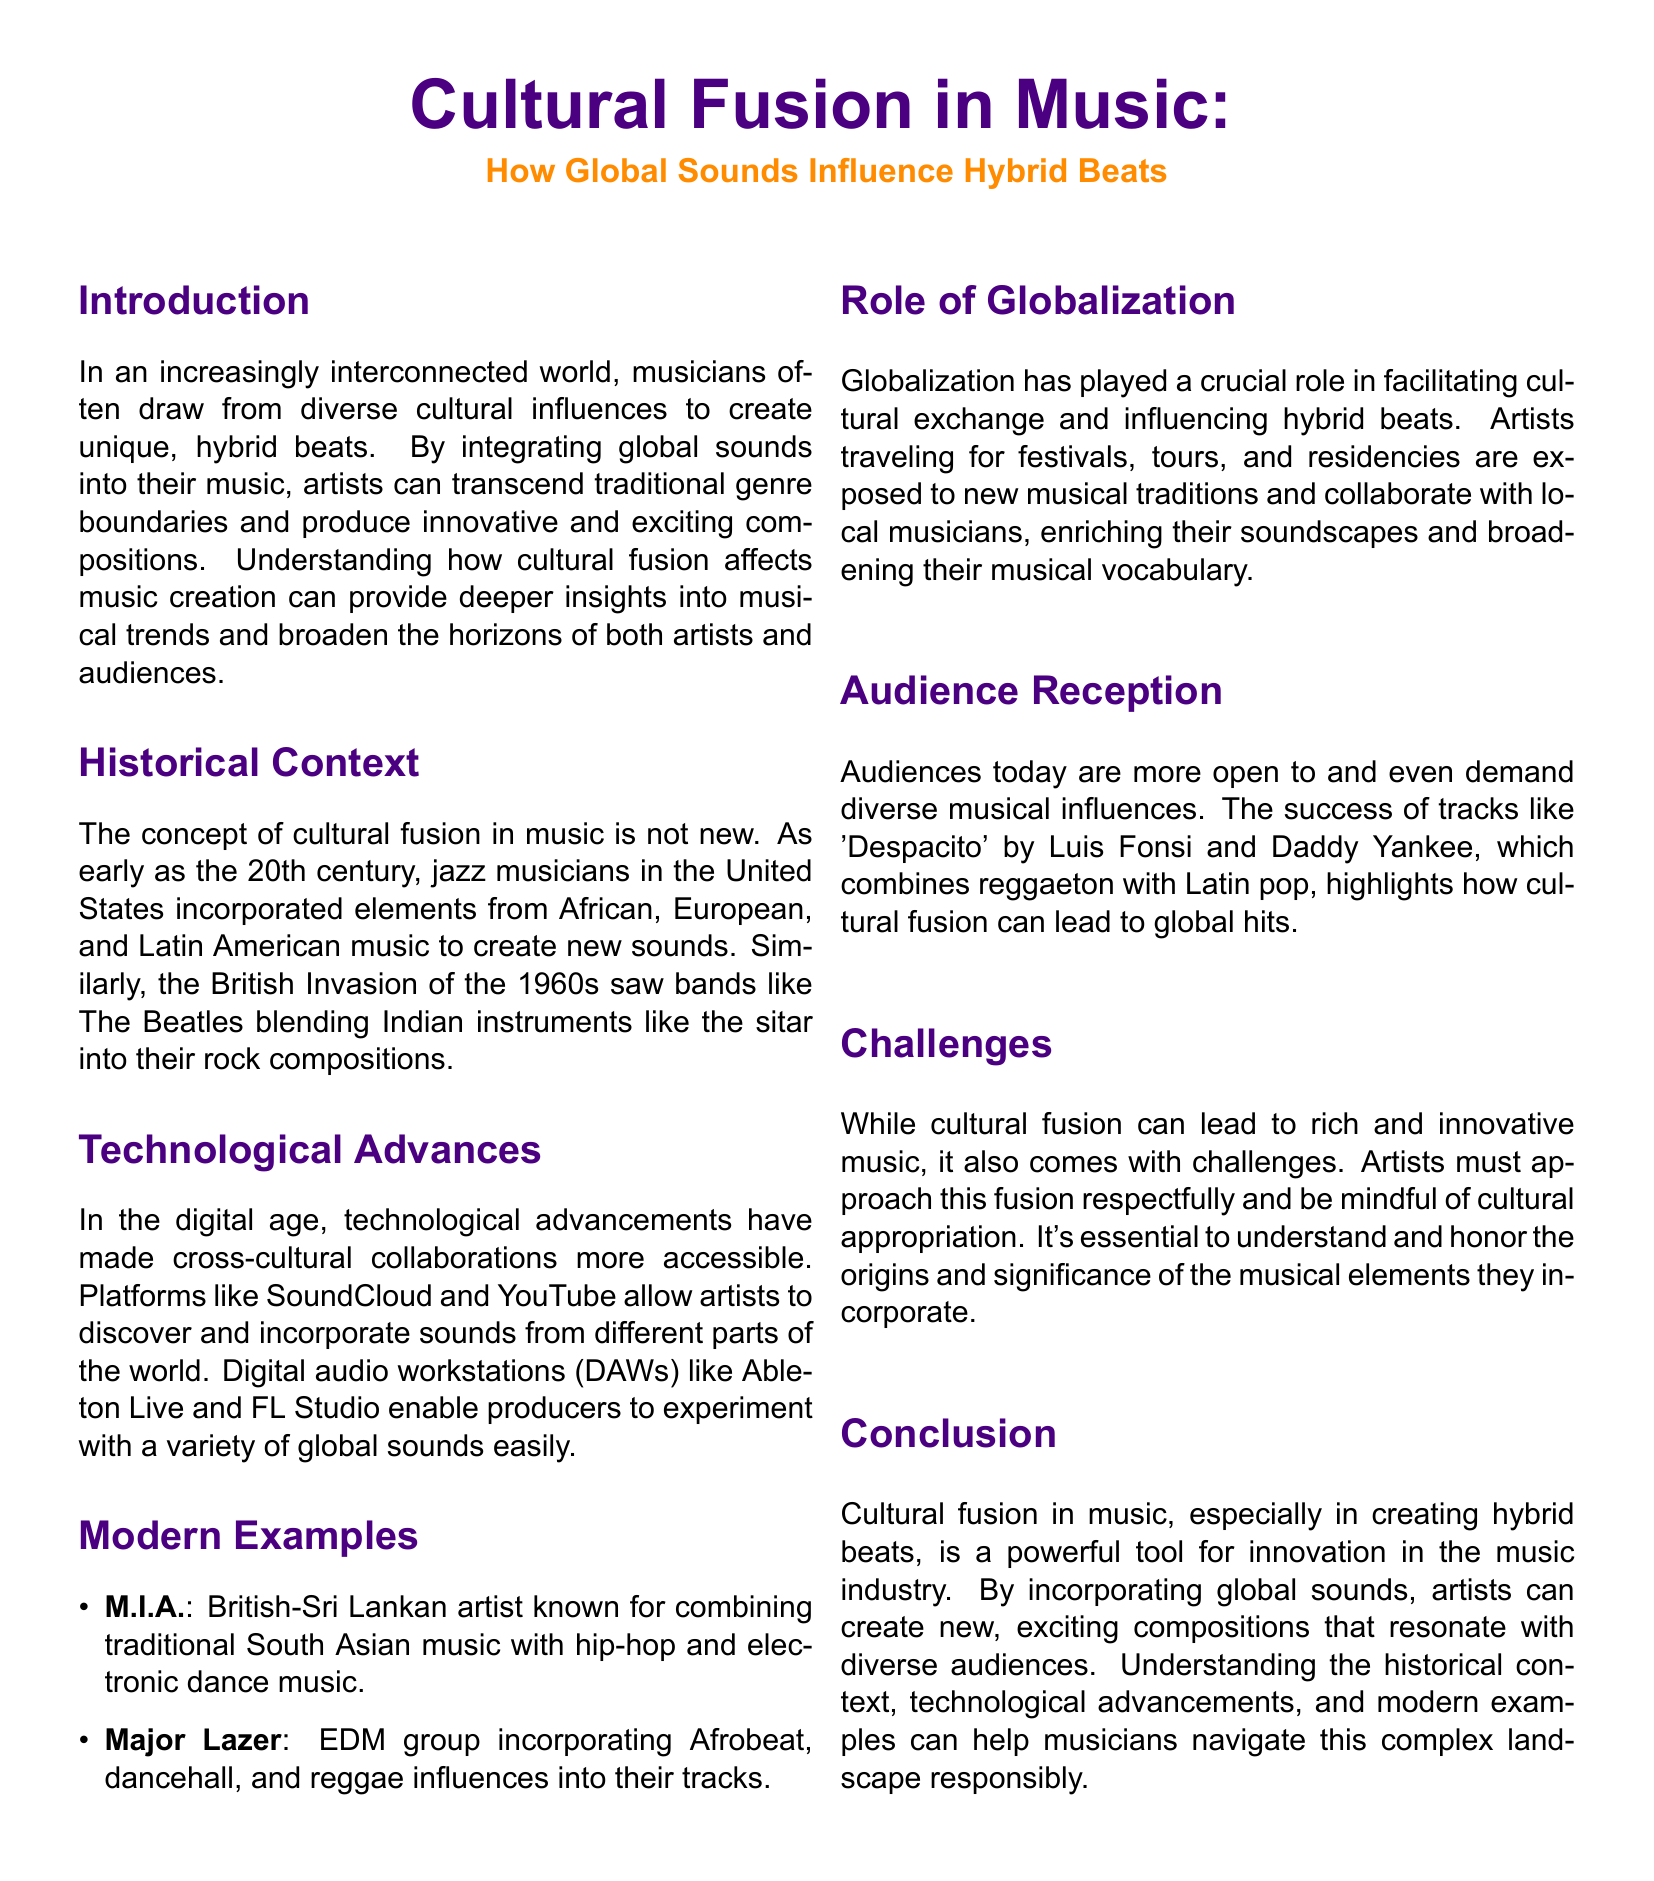What is the main topic of the paper? The main topic is the influence of global sounds on hybrid beats in music.
Answer: Cultural Fusion in Music Who is a notable artist mentioned for combining South Asian music with hip-hop? The document specifically mentions a British-Sri Lankan artist known for this combination.
Answer: M.I.A What technological tools are mentioned as enablers for sound experimentation? The document lists digital audio workstations that help in sound experimentation.
Answer: Ableton Live and FL Studio What was a significant cultural influence on jazz musicians in the 20th century? The document states that jazz musicians incorporated elements from various musical traditions.
Answer: African, European, and Latin American music Which song is cited as an example of cultural fusion achieving global success? The document points to a specific track that highlights the successful blend of different musical styles.
Answer: Despacito What challenge does cultural fusion pose for artists? The document indicates that cultural fusion brings about a specific concern in its practice.
Answer: Cultural appropriation In which decade did The Beatles blend Indian instruments into their music? The historical context provided points to a specific time period for this event.
Answer: 1960s What has facilitated cultural exchange according to the text? The paper highlights a certain phenomenon that has encouraged this exchange in music.
Answer: Globalization What is the primary benefit of incorporating global sounds into music according to the conclusion? The document summarizes a key advantage of this practice in the music industry.
Answer: Innovation 